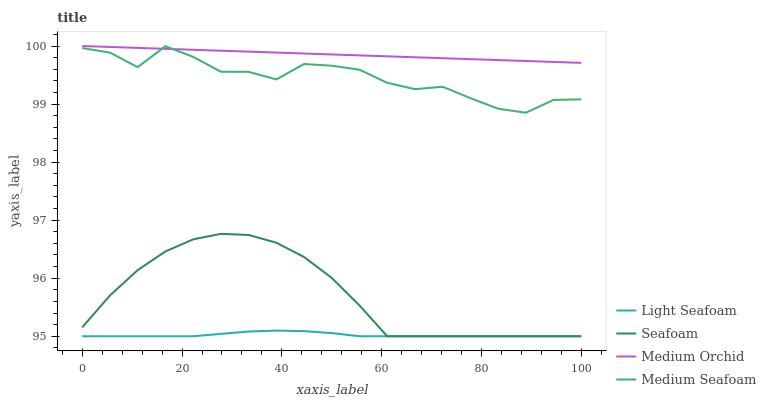Does Light Seafoam have the minimum area under the curve?
Answer yes or no. Yes. Does Medium Orchid have the maximum area under the curve?
Answer yes or no. Yes. Does Seafoam have the minimum area under the curve?
Answer yes or no. No. Does Seafoam have the maximum area under the curve?
Answer yes or no. No. Is Medium Orchid the smoothest?
Answer yes or no. Yes. Is Medium Seafoam the roughest?
Answer yes or no. Yes. Is Light Seafoam the smoothest?
Answer yes or no. No. Is Light Seafoam the roughest?
Answer yes or no. No. Does Light Seafoam have the lowest value?
Answer yes or no. Yes. Does Medium Seafoam have the lowest value?
Answer yes or no. No. Does Medium Orchid have the highest value?
Answer yes or no. Yes. Does Seafoam have the highest value?
Answer yes or no. No. Is Seafoam less than Medium Orchid?
Answer yes or no. Yes. Is Medium Seafoam greater than Light Seafoam?
Answer yes or no. Yes. Does Seafoam intersect Light Seafoam?
Answer yes or no. Yes. Is Seafoam less than Light Seafoam?
Answer yes or no. No. Is Seafoam greater than Light Seafoam?
Answer yes or no. No. Does Seafoam intersect Medium Orchid?
Answer yes or no. No. 